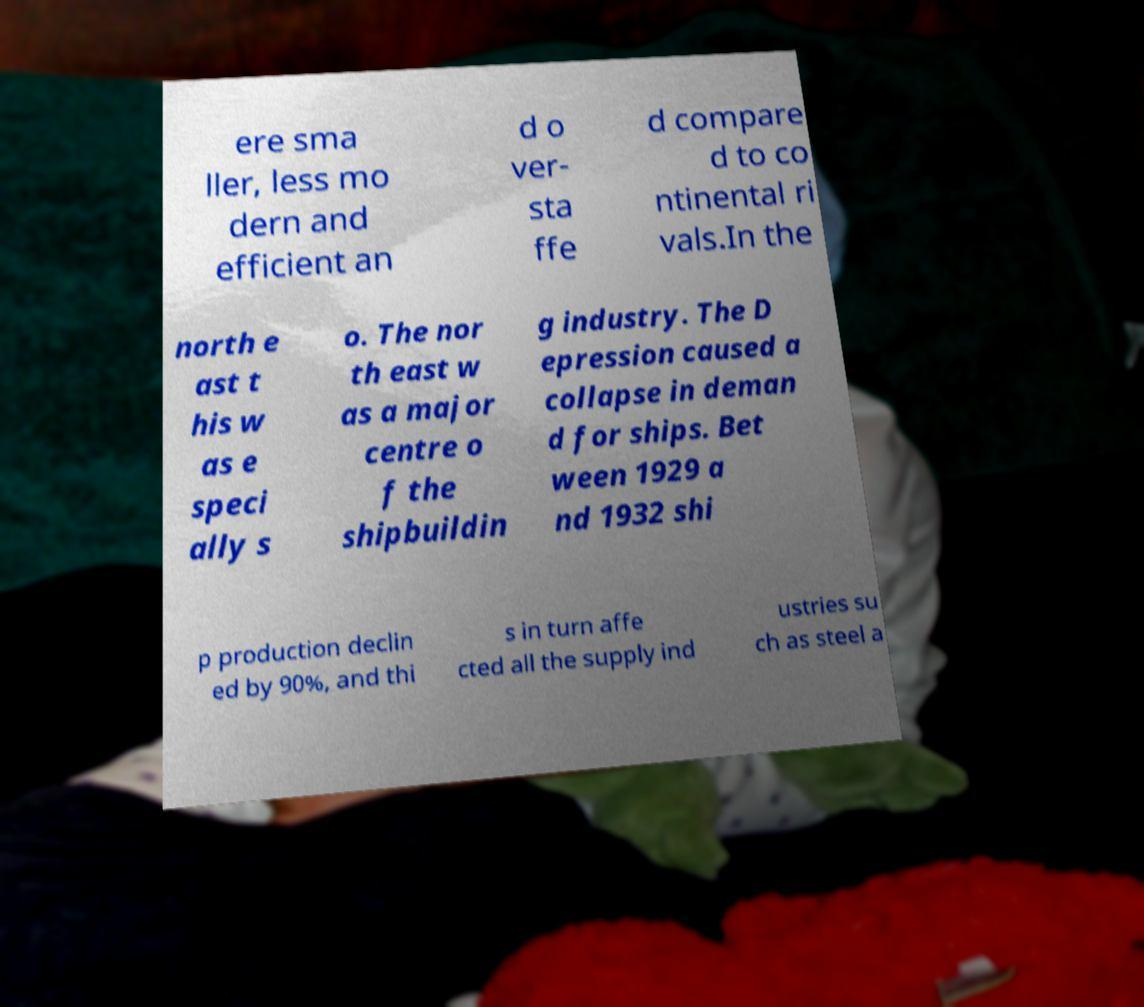Could you assist in decoding the text presented in this image and type it out clearly? ere sma ller, less mo dern and efficient an d o ver- sta ffe d compare d to co ntinental ri vals.In the north e ast t his w as e speci ally s o. The nor th east w as a major centre o f the shipbuildin g industry. The D epression caused a collapse in deman d for ships. Bet ween 1929 a nd 1932 shi p production declin ed by 90%, and thi s in turn affe cted all the supply ind ustries su ch as steel a 